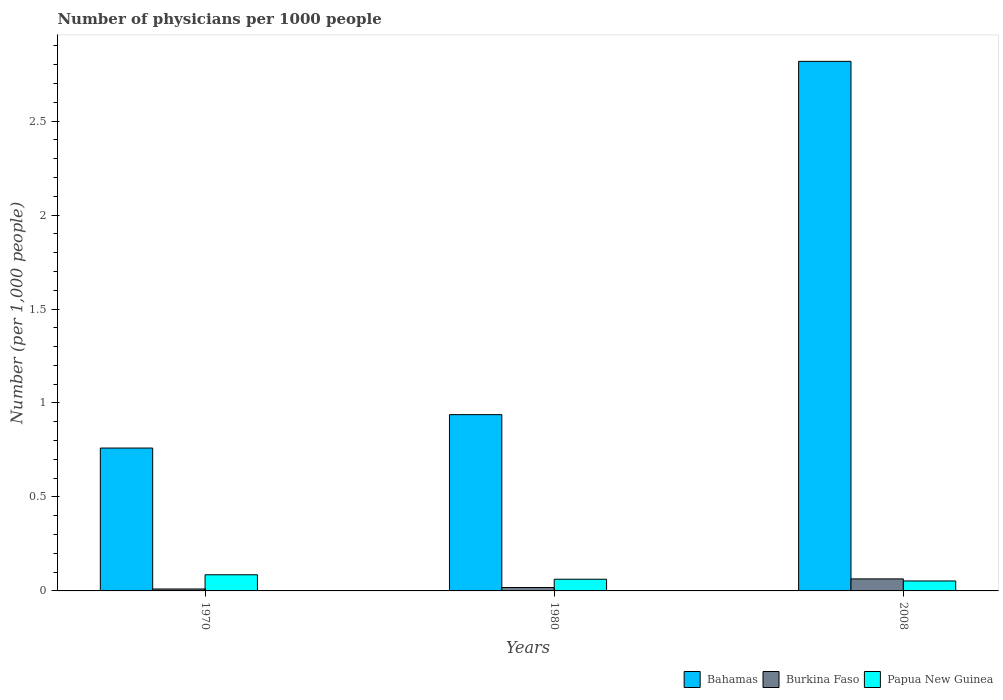How many different coloured bars are there?
Offer a very short reply. 3. How many groups of bars are there?
Keep it short and to the point. 3. Are the number of bars per tick equal to the number of legend labels?
Ensure brevity in your answer.  Yes. How many bars are there on the 2nd tick from the left?
Ensure brevity in your answer.  3. How many bars are there on the 2nd tick from the right?
Your response must be concise. 3. What is the label of the 1st group of bars from the left?
Give a very brief answer. 1970. What is the number of physicians in Papua New Guinea in 2008?
Keep it short and to the point. 0.05. Across all years, what is the maximum number of physicians in Papua New Guinea?
Give a very brief answer. 0.09. Across all years, what is the minimum number of physicians in Papua New Guinea?
Offer a terse response. 0.05. In which year was the number of physicians in Bahamas minimum?
Offer a very short reply. 1970. What is the total number of physicians in Burkina Faso in the graph?
Keep it short and to the point. 0.09. What is the difference between the number of physicians in Burkina Faso in 1970 and that in 2008?
Your response must be concise. -0.05. What is the difference between the number of physicians in Burkina Faso in 2008 and the number of physicians in Bahamas in 1980?
Keep it short and to the point. -0.87. What is the average number of physicians in Papua New Guinea per year?
Your answer should be compact. 0.07. In the year 1980, what is the difference between the number of physicians in Bahamas and number of physicians in Papua New Guinea?
Make the answer very short. 0.88. What is the ratio of the number of physicians in Bahamas in 1980 to that in 2008?
Provide a succinct answer. 0.33. Is the difference between the number of physicians in Bahamas in 1970 and 2008 greater than the difference between the number of physicians in Papua New Guinea in 1970 and 2008?
Your response must be concise. No. What is the difference between the highest and the second highest number of physicians in Burkina Faso?
Provide a short and direct response. 0.05. What is the difference between the highest and the lowest number of physicians in Papua New Guinea?
Make the answer very short. 0.03. In how many years, is the number of physicians in Bahamas greater than the average number of physicians in Bahamas taken over all years?
Offer a very short reply. 1. What does the 3rd bar from the left in 1980 represents?
Offer a very short reply. Papua New Guinea. What does the 1st bar from the right in 1980 represents?
Offer a terse response. Papua New Guinea. How many bars are there?
Your response must be concise. 9. Are the values on the major ticks of Y-axis written in scientific E-notation?
Keep it short and to the point. No. Does the graph contain any zero values?
Give a very brief answer. No. Where does the legend appear in the graph?
Provide a short and direct response. Bottom right. What is the title of the graph?
Your response must be concise. Number of physicians per 1000 people. Does "Georgia" appear as one of the legend labels in the graph?
Provide a short and direct response. No. What is the label or title of the X-axis?
Give a very brief answer. Years. What is the label or title of the Y-axis?
Give a very brief answer. Number (per 1,0 people). What is the Number (per 1,000 people) in Bahamas in 1970?
Provide a succinct answer. 0.76. What is the Number (per 1,000 people) of Burkina Faso in 1970?
Your answer should be compact. 0.01. What is the Number (per 1,000 people) of Papua New Guinea in 1970?
Keep it short and to the point. 0.09. What is the Number (per 1,000 people) in Bahamas in 1980?
Offer a terse response. 0.94. What is the Number (per 1,000 people) in Burkina Faso in 1980?
Provide a succinct answer. 0.02. What is the Number (per 1,000 people) of Papua New Guinea in 1980?
Offer a terse response. 0.06. What is the Number (per 1,000 people) of Bahamas in 2008?
Your response must be concise. 2.82. What is the Number (per 1,000 people) of Burkina Faso in 2008?
Provide a short and direct response. 0.06. What is the Number (per 1,000 people) in Papua New Guinea in 2008?
Provide a succinct answer. 0.05. Across all years, what is the maximum Number (per 1,000 people) of Bahamas?
Your response must be concise. 2.82. Across all years, what is the maximum Number (per 1,000 people) of Burkina Faso?
Your answer should be very brief. 0.06. Across all years, what is the maximum Number (per 1,000 people) of Papua New Guinea?
Provide a succinct answer. 0.09. Across all years, what is the minimum Number (per 1,000 people) in Bahamas?
Offer a terse response. 0.76. Across all years, what is the minimum Number (per 1,000 people) in Burkina Faso?
Make the answer very short. 0.01. Across all years, what is the minimum Number (per 1,000 people) of Papua New Guinea?
Make the answer very short. 0.05. What is the total Number (per 1,000 people) in Bahamas in the graph?
Ensure brevity in your answer.  4.52. What is the total Number (per 1,000 people) in Burkina Faso in the graph?
Your answer should be very brief. 0.09. What is the total Number (per 1,000 people) of Papua New Guinea in the graph?
Make the answer very short. 0.2. What is the difference between the Number (per 1,000 people) in Bahamas in 1970 and that in 1980?
Keep it short and to the point. -0.18. What is the difference between the Number (per 1,000 people) of Burkina Faso in 1970 and that in 1980?
Provide a short and direct response. -0.01. What is the difference between the Number (per 1,000 people) in Papua New Guinea in 1970 and that in 1980?
Ensure brevity in your answer.  0.02. What is the difference between the Number (per 1,000 people) of Bahamas in 1970 and that in 2008?
Offer a terse response. -2.06. What is the difference between the Number (per 1,000 people) in Burkina Faso in 1970 and that in 2008?
Ensure brevity in your answer.  -0.05. What is the difference between the Number (per 1,000 people) of Papua New Guinea in 1970 and that in 2008?
Your answer should be compact. 0.03. What is the difference between the Number (per 1,000 people) of Bahamas in 1980 and that in 2008?
Ensure brevity in your answer.  -1.88. What is the difference between the Number (per 1,000 people) in Burkina Faso in 1980 and that in 2008?
Your response must be concise. -0.05. What is the difference between the Number (per 1,000 people) of Papua New Guinea in 1980 and that in 2008?
Your answer should be compact. 0.01. What is the difference between the Number (per 1,000 people) in Bahamas in 1970 and the Number (per 1,000 people) in Burkina Faso in 1980?
Your answer should be compact. 0.74. What is the difference between the Number (per 1,000 people) of Bahamas in 1970 and the Number (per 1,000 people) of Papua New Guinea in 1980?
Offer a very short reply. 0.7. What is the difference between the Number (per 1,000 people) of Burkina Faso in 1970 and the Number (per 1,000 people) of Papua New Guinea in 1980?
Provide a succinct answer. -0.05. What is the difference between the Number (per 1,000 people) of Bahamas in 1970 and the Number (per 1,000 people) of Burkina Faso in 2008?
Give a very brief answer. 0.7. What is the difference between the Number (per 1,000 people) of Bahamas in 1970 and the Number (per 1,000 people) of Papua New Guinea in 2008?
Make the answer very short. 0.71. What is the difference between the Number (per 1,000 people) of Burkina Faso in 1970 and the Number (per 1,000 people) of Papua New Guinea in 2008?
Provide a short and direct response. -0.04. What is the difference between the Number (per 1,000 people) of Bahamas in 1980 and the Number (per 1,000 people) of Burkina Faso in 2008?
Make the answer very short. 0.87. What is the difference between the Number (per 1,000 people) in Bahamas in 1980 and the Number (per 1,000 people) in Papua New Guinea in 2008?
Ensure brevity in your answer.  0.89. What is the difference between the Number (per 1,000 people) in Burkina Faso in 1980 and the Number (per 1,000 people) in Papua New Guinea in 2008?
Give a very brief answer. -0.03. What is the average Number (per 1,000 people) in Bahamas per year?
Offer a terse response. 1.51. What is the average Number (per 1,000 people) in Burkina Faso per year?
Your answer should be very brief. 0.03. What is the average Number (per 1,000 people) of Papua New Guinea per year?
Your answer should be compact. 0.07. In the year 1970, what is the difference between the Number (per 1,000 people) of Bahamas and Number (per 1,000 people) of Burkina Faso?
Keep it short and to the point. 0.75. In the year 1970, what is the difference between the Number (per 1,000 people) in Bahamas and Number (per 1,000 people) in Papua New Guinea?
Your answer should be very brief. 0.67. In the year 1970, what is the difference between the Number (per 1,000 people) in Burkina Faso and Number (per 1,000 people) in Papua New Guinea?
Give a very brief answer. -0.08. In the year 1980, what is the difference between the Number (per 1,000 people) in Bahamas and Number (per 1,000 people) in Burkina Faso?
Your answer should be compact. 0.92. In the year 1980, what is the difference between the Number (per 1,000 people) in Bahamas and Number (per 1,000 people) in Papua New Guinea?
Offer a terse response. 0.88. In the year 1980, what is the difference between the Number (per 1,000 people) in Burkina Faso and Number (per 1,000 people) in Papua New Guinea?
Your response must be concise. -0.04. In the year 2008, what is the difference between the Number (per 1,000 people) in Bahamas and Number (per 1,000 people) in Burkina Faso?
Offer a very short reply. 2.75. In the year 2008, what is the difference between the Number (per 1,000 people) in Bahamas and Number (per 1,000 people) in Papua New Guinea?
Give a very brief answer. 2.77. In the year 2008, what is the difference between the Number (per 1,000 people) of Burkina Faso and Number (per 1,000 people) of Papua New Guinea?
Your response must be concise. 0.01. What is the ratio of the Number (per 1,000 people) of Bahamas in 1970 to that in 1980?
Give a very brief answer. 0.81. What is the ratio of the Number (per 1,000 people) in Burkina Faso in 1970 to that in 1980?
Keep it short and to the point. 0.57. What is the ratio of the Number (per 1,000 people) in Papua New Guinea in 1970 to that in 1980?
Offer a very short reply. 1.38. What is the ratio of the Number (per 1,000 people) of Bahamas in 1970 to that in 2008?
Make the answer very short. 0.27. What is the ratio of the Number (per 1,000 people) of Burkina Faso in 1970 to that in 2008?
Your response must be concise. 0.16. What is the ratio of the Number (per 1,000 people) of Papua New Guinea in 1970 to that in 2008?
Provide a succinct answer. 1.62. What is the ratio of the Number (per 1,000 people) in Bahamas in 1980 to that in 2008?
Offer a very short reply. 0.33. What is the ratio of the Number (per 1,000 people) of Burkina Faso in 1980 to that in 2008?
Ensure brevity in your answer.  0.28. What is the ratio of the Number (per 1,000 people) in Papua New Guinea in 1980 to that in 2008?
Your answer should be compact. 1.17. What is the difference between the highest and the second highest Number (per 1,000 people) of Bahamas?
Offer a terse response. 1.88. What is the difference between the highest and the second highest Number (per 1,000 people) of Burkina Faso?
Your answer should be compact. 0.05. What is the difference between the highest and the second highest Number (per 1,000 people) in Papua New Guinea?
Give a very brief answer. 0.02. What is the difference between the highest and the lowest Number (per 1,000 people) of Bahamas?
Offer a very short reply. 2.06. What is the difference between the highest and the lowest Number (per 1,000 people) in Burkina Faso?
Offer a terse response. 0.05. What is the difference between the highest and the lowest Number (per 1,000 people) of Papua New Guinea?
Provide a short and direct response. 0.03. 